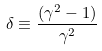Convert formula to latex. <formula><loc_0><loc_0><loc_500><loc_500>\delta \equiv \frac { ( \gamma ^ { 2 } - 1 ) } { \gamma ^ { 2 } }</formula> 